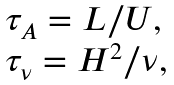Convert formula to latex. <formula><loc_0><loc_0><loc_500><loc_500>\begin{array} { l l } \tau _ { A } = L / U , \\ \tau _ { \nu } = H ^ { 2 } / \nu , \end{array}</formula> 